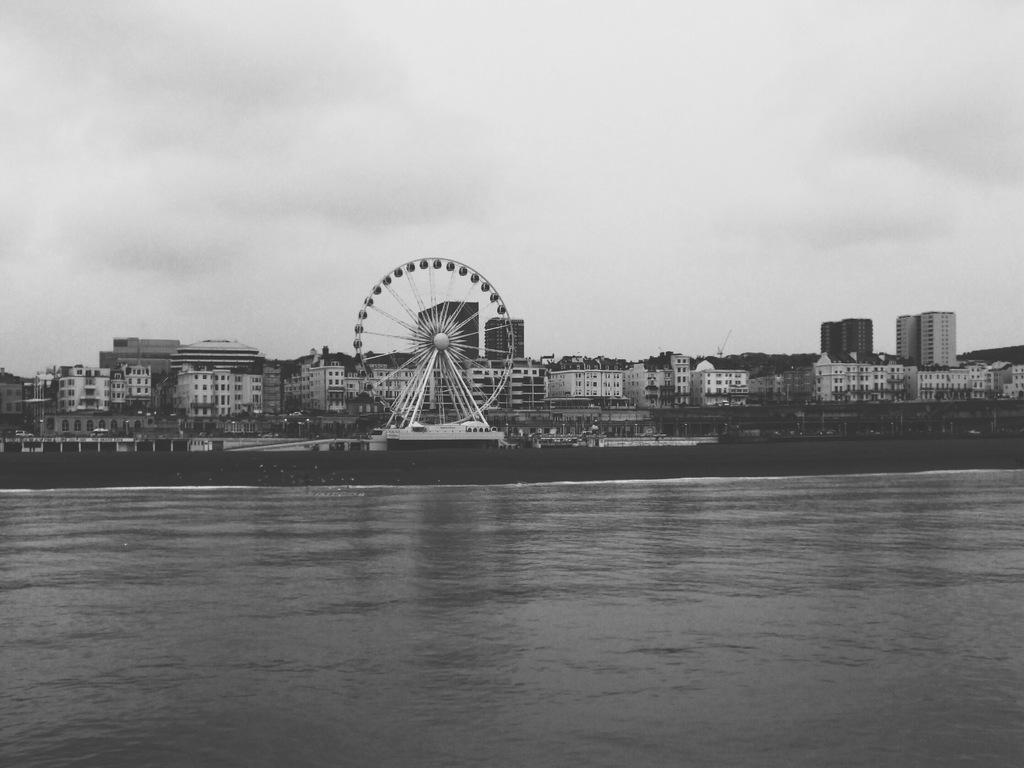What is the color scheme of the image? The image is black and white. What natural element can be seen in the image? There is water visible in the image. What type of amusement ride is present in the image? There is a Ferris wheel in the image. What type of structures are visible in the image? There are buildings in the image. What type of vegetation is present in the image? There are trees in the image. What is visible in the background of the image? The sky is visible in the background of the image. What type of wool is being spun by the governor in the image? There is no governor or wool present in the image. 